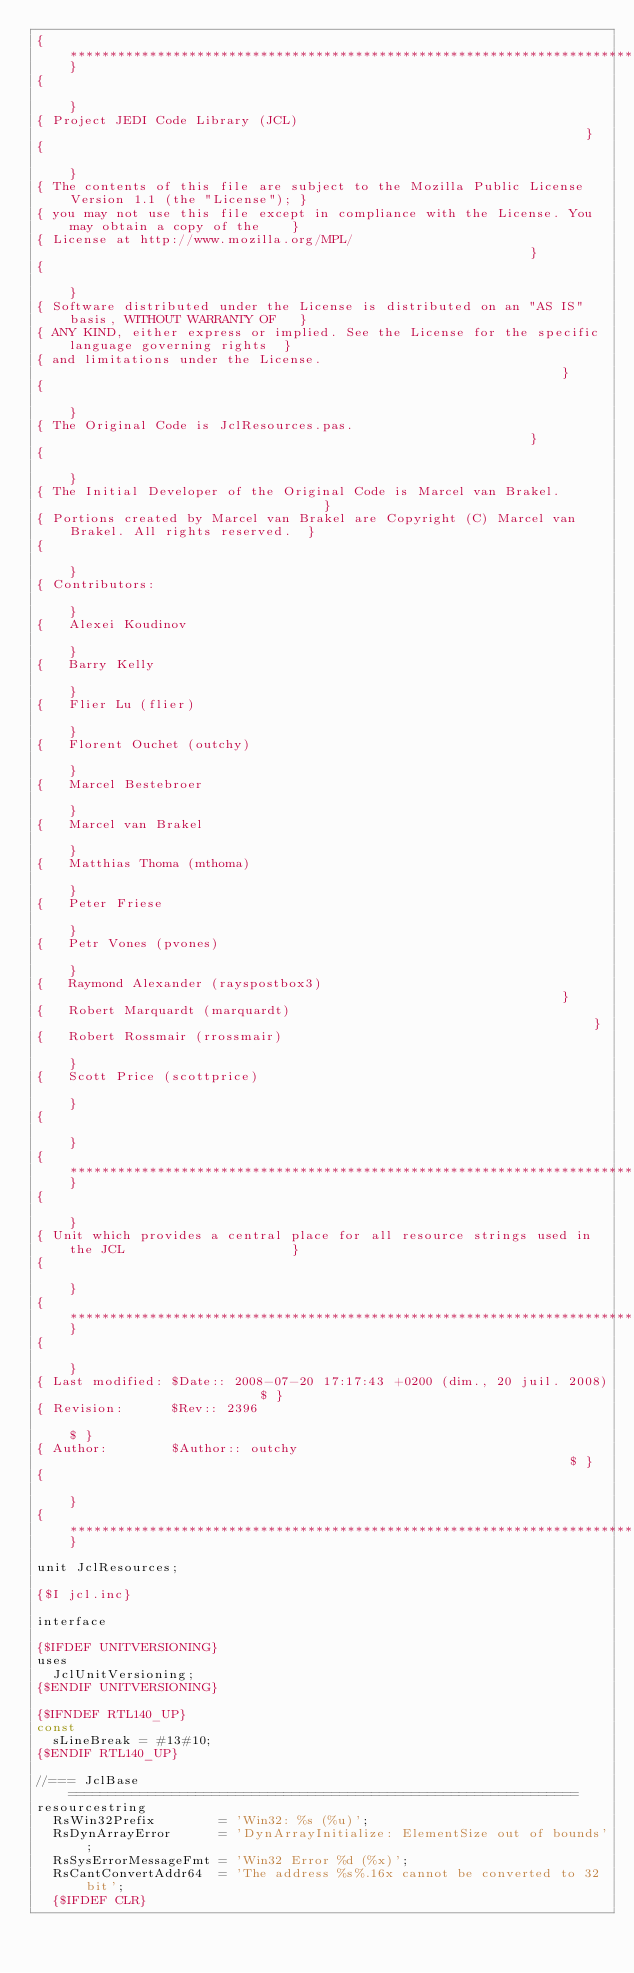Convert code to text. <code><loc_0><loc_0><loc_500><loc_500><_Pascal_>{**************************************************************************************************}
{                                                                                                  }
{ Project JEDI Code Library (JCL)                                                                  }
{                                                                                                  }
{ The contents of this file are subject to the Mozilla Public License Version 1.1 (the "License"); }
{ you may not use this file except in compliance with the License. You may obtain a copy of the    }
{ License at http://www.mozilla.org/MPL/                                                           }
{                                                                                                  }
{ Software distributed under the License is distributed on an "AS IS" basis, WITHOUT WARRANTY OF   }
{ ANY KIND, either express or implied. See the License for the specific language governing rights  }
{ and limitations under the License.                                                               }
{                                                                                                  }
{ The Original Code is JclResources.pas.                                                           }
{                                                                                                  }
{ The Initial Developer of the Original Code is Marcel van Brakel.                                 }
{ Portions created by Marcel van Brakel are Copyright (C) Marcel van Brakel. All rights reserved.  }
{                                                                                                  }
{ Contributors:                                                                                    }
{   Alexei Koudinov                                                                                }
{   Barry Kelly                                                                                    }
{   Flier Lu (flier)                                                                               }
{   Florent Ouchet (outchy)                                                                        }
{   Marcel Bestebroer                                                                              }
{   Marcel van Brakel                                                                              }
{   Matthias Thoma (mthoma)                                                                        }
{   Peter Friese                                                                                   }
{   Petr Vones (pvones)                                                                            }
{   Raymond Alexander (rayspostbox3)                                                               }
{   Robert Marquardt (marquardt)                                                                   }
{   Robert Rossmair (rrossmair)                                                                    }
{   Scott Price (scottprice)                                                                       }
{                                                                                                  }
{**************************************************************************************************}
{                                                                                                  }
{ Unit which provides a central place for all resource strings used in the JCL                     }
{                                                                                                  }
{**************************************************************************************************}
{                                                                                                  }
{ Last modified: $Date:: 2008-07-20 17:17:43 +0200 (dim., 20 juil. 2008)                        $ }
{ Revision:      $Rev:: 2396                                                                     $ }
{ Author:        $Author:: outchy                                                                $ }
{                                                                                                  }
{**************************************************************************************************}

unit JclResources;

{$I jcl.inc}

interface

{$IFDEF UNITVERSIONING}
uses
  JclUnitVersioning;
{$ENDIF UNITVERSIONING}

{$IFNDEF RTL140_UP}
const
  sLineBreak = #13#10;
{$ENDIF RTL140_UP}

//=== JclBase ================================================================
resourcestring
  RsWin32Prefix        = 'Win32: %s (%u)';
  RsDynArrayError      = 'DynArrayInitialize: ElementSize out of bounds';
  RsSysErrorMessageFmt = 'Win32 Error %d (%x)';
  RsCantConvertAddr64  = 'The address %s%.16x cannot be converted to 32 bit';
  {$IFDEF CLR}</code> 